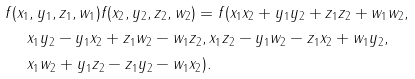<formula> <loc_0><loc_0><loc_500><loc_500>& f ( x _ { 1 } , y _ { 1 } , z _ { 1 } , w _ { 1 } ) f ( x _ { 2 } , y _ { 2 } , z _ { 2 } , w _ { 2 } ) = f ( x _ { 1 } x _ { 2 } + y _ { 1 } y _ { 2 } + z _ { 1 } z _ { 2 } + w _ { 1 } w _ { 2 } , \, \\ & \quad \ x _ { 1 } y _ { 2 } - y _ { 1 } x _ { 2 } + z _ { 1 } w _ { 2 } - w _ { 1 } z _ { 2 } , x _ { 1 } z _ { 2 } - y _ { 1 } w _ { 2 } - z _ { 1 } x _ { 2 } + w _ { 1 } y _ { 2 } , \, \\ & \quad \ x _ { 1 } w _ { 2 } + y _ { 1 } z _ { 2 } - z _ { 1 } y _ { 2 } - w _ { 1 } x _ { 2 } ) .</formula> 